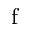Convert formula to latex. <formula><loc_0><loc_0><loc_500><loc_500>f</formula> 